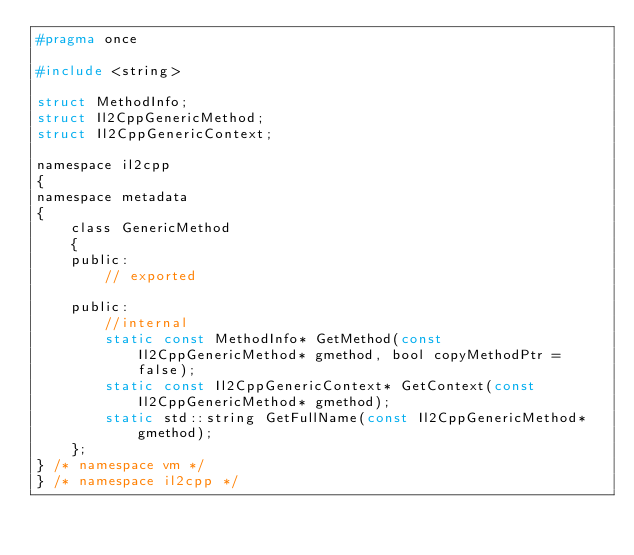<code> <loc_0><loc_0><loc_500><loc_500><_C_>#pragma once

#include <string>

struct MethodInfo;
struct Il2CppGenericMethod;
struct Il2CppGenericContext;

namespace il2cpp
{
namespace metadata
{
    class GenericMethod
    {
    public:
        // exported

    public:
        //internal
        static const MethodInfo* GetMethod(const Il2CppGenericMethod* gmethod, bool copyMethodPtr = false);
        static const Il2CppGenericContext* GetContext(const Il2CppGenericMethod* gmethod);
        static std::string GetFullName(const Il2CppGenericMethod* gmethod);
    };
} /* namespace vm */
} /* namespace il2cpp */
</code> 